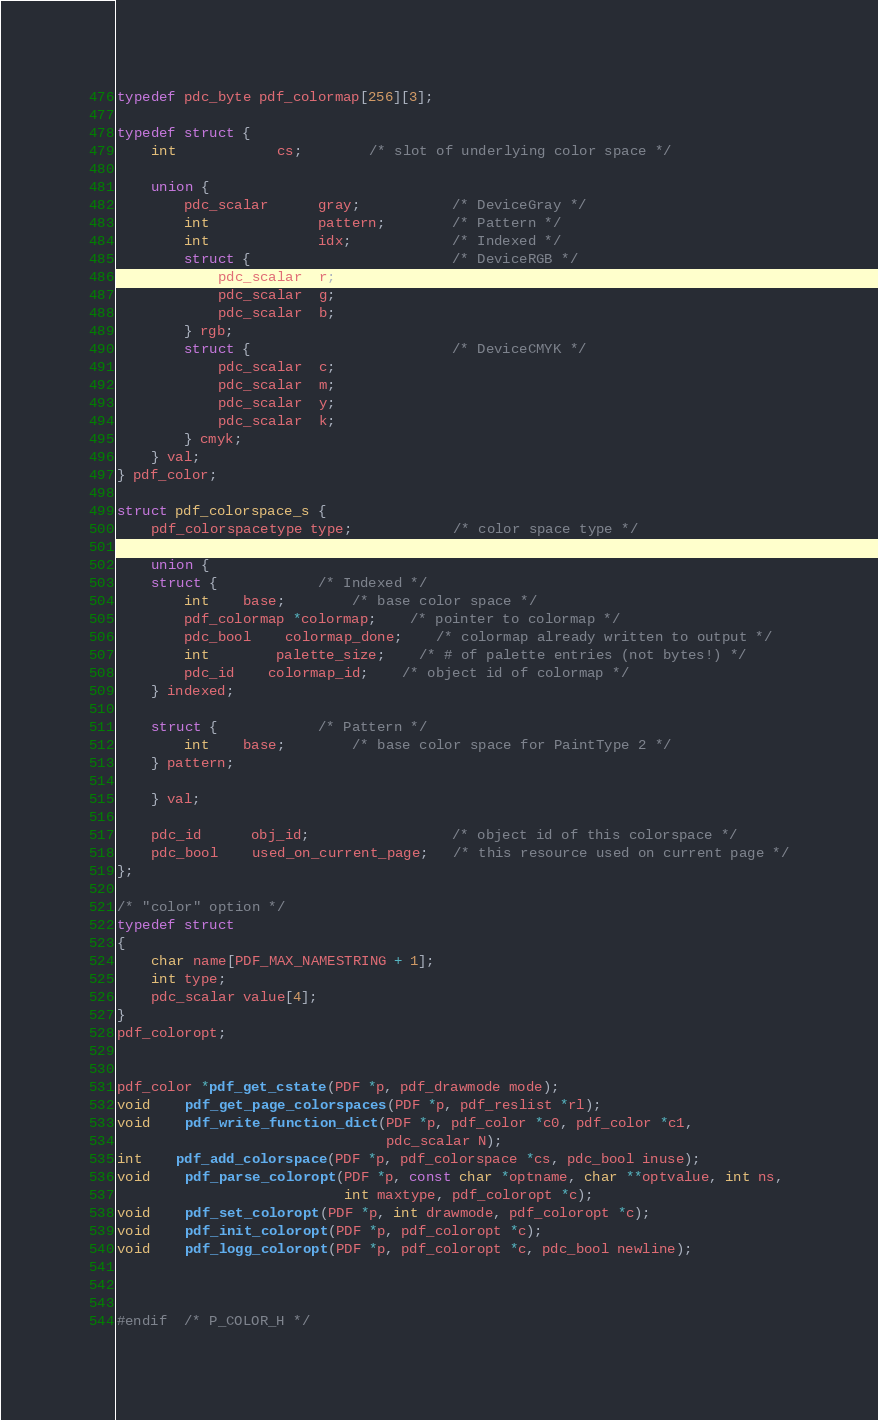<code> <loc_0><loc_0><loc_500><loc_500><_C_>
typedef pdc_byte pdf_colormap[256][3];

typedef struct {
    int      		cs;     	/* slot of underlying color space */

    union {
        pdc_scalar      gray;           /* DeviceGray */
        int             pattern;        /* Pattern */
        int             idx;        	/* Indexed */
        struct {                        /* DeviceRGB */
            pdc_scalar  r;
            pdc_scalar  g;
            pdc_scalar  b;
        } rgb;
        struct {                        /* DeviceCMYK */
            pdc_scalar  c;
            pdc_scalar  m;
            pdc_scalar  y;
            pdc_scalar  k;
        } cmyk;
    } val;
} pdf_color;

struct pdf_colorspace_s {
    pdf_colorspacetype type;            /* color space type */

    union {
	struct {			/* Indexed */
	    int   	base;		/* base color space */
	    pdf_colormap *colormap;	/* pointer to colormap */
	    pdc_bool	colormap_done;	/* colormap already written to output */
	    int		palette_size;	/* # of palette entries (not bytes!) */
	    pdc_id	colormap_id;	/* object id of colormap */
	} indexed;

	struct {			/* Pattern */
	    int   	base;		/* base color space for PaintType 2 */
	} pattern;

    } val;

    pdc_id      obj_id;                 /* object id of this colorspace */
    pdc_bool    used_on_current_page;   /* this resource used on current page */
};

/* "color" option */
typedef struct
{
    char name[PDF_MAX_NAMESTRING + 1];
    int type;
    pdc_scalar value[4];
}
pdf_coloropt;


pdf_color *pdf_get_cstate(PDF *p, pdf_drawmode mode);
void    pdf_get_page_colorspaces(PDF *p, pdf_reslist *rl);
void    pdf_write_function_dict(PDF *p, pdf_color *c0, pdf_color *c1,
                                pdc_scalar N);
int	pdf_add_colorspace(PDF *p, pdf_colorspace *cs, pdc_bool inuse);
void    pdf_parse_coloropt(PDF *p, const char *optname, char **optvalue, int ns,
                           int maxtype, pdf_coloropt *c);
void    pdf_set_coloropt(PDF *p, int drawmode, pdf_coloropt *c);
void    pdf_init_coloropt(PDF *p, pdf_coloropt *c);
void    pdf_logg_coloropt(PDF *p, pdf_coloropt *c, pdc_bool newline);



#endif  /* P_COLOR_H */

</code> 